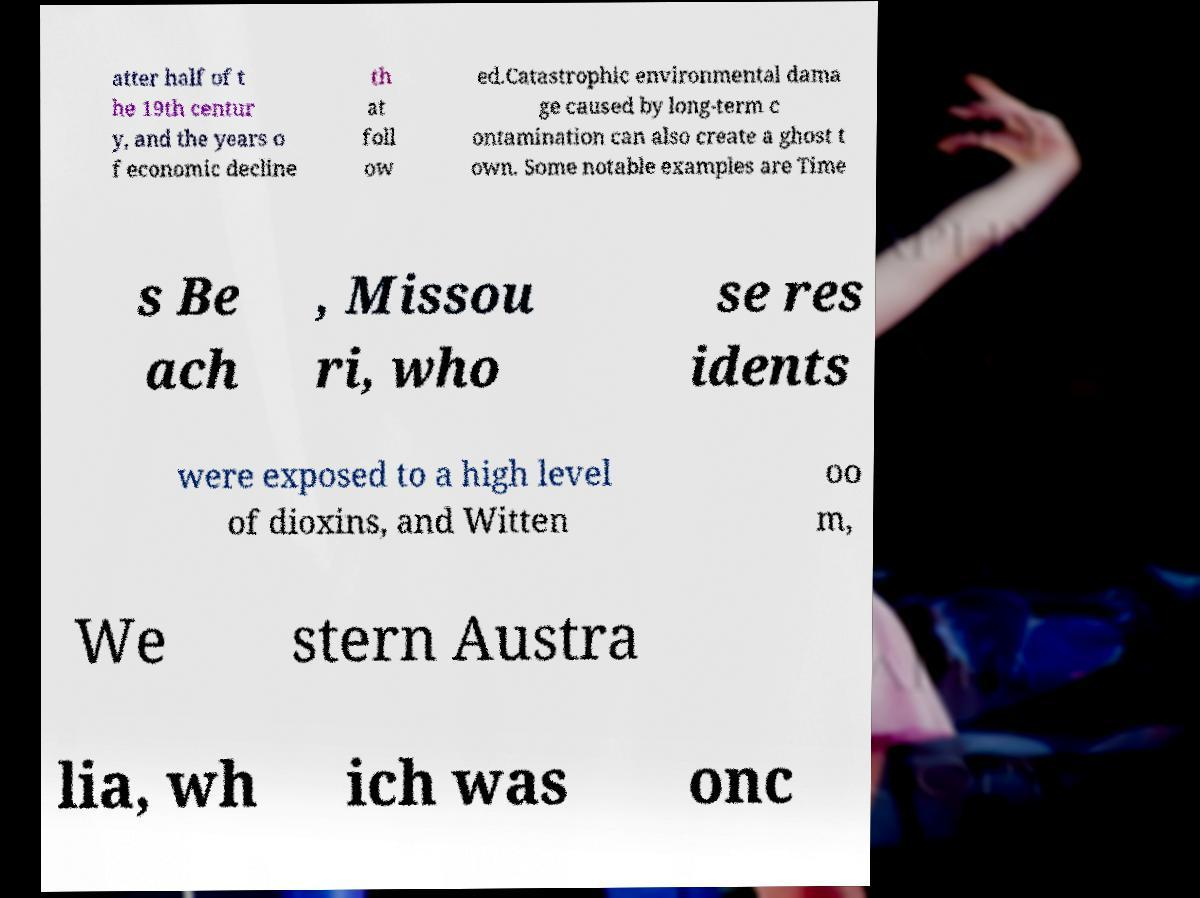I need the written content from this picture converted into text. Can you do that? atter half of t he 19th centur y, and the years o f economic decline th at foll ow ed.Catastrophic environmental dama ge caused by long-term c ontamination can also create a ghost t own. Some notable examples are Time s Be ach , Missou ri, who se res idents were exposed to a high level of dioxins, and Witten oo m, We stern Austra lia, wh ich was onc 